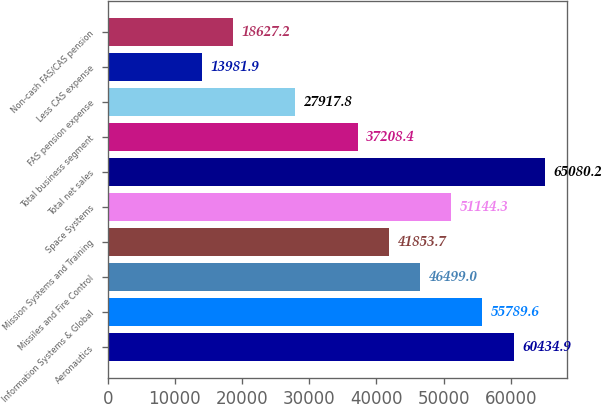Convert chart to OTSL. <chart><loc_0><loc_0><loc_500><loc_500><bar_chart><fcel>Aeronautics<fcel>Information Systems & Global<fcel>Missiles and Fire Control<fcel>Mission Systems and Training<fcel>Space Systems<fcel>Total net sales<fcel>Total business segment<fcel>FAS pension expense<fcel>Less CAS expense<fcel>Non-cash FAS/CAS pension<nl><fcel>60434.9<fcel>55789.6<fcel>46499<fcel>41853.7<fcel>51144.3<fcel>65080.2<fcel>37208.4<fcel>27917.8<fcel>13981.9<fcel>18627.2<nl></chart> 